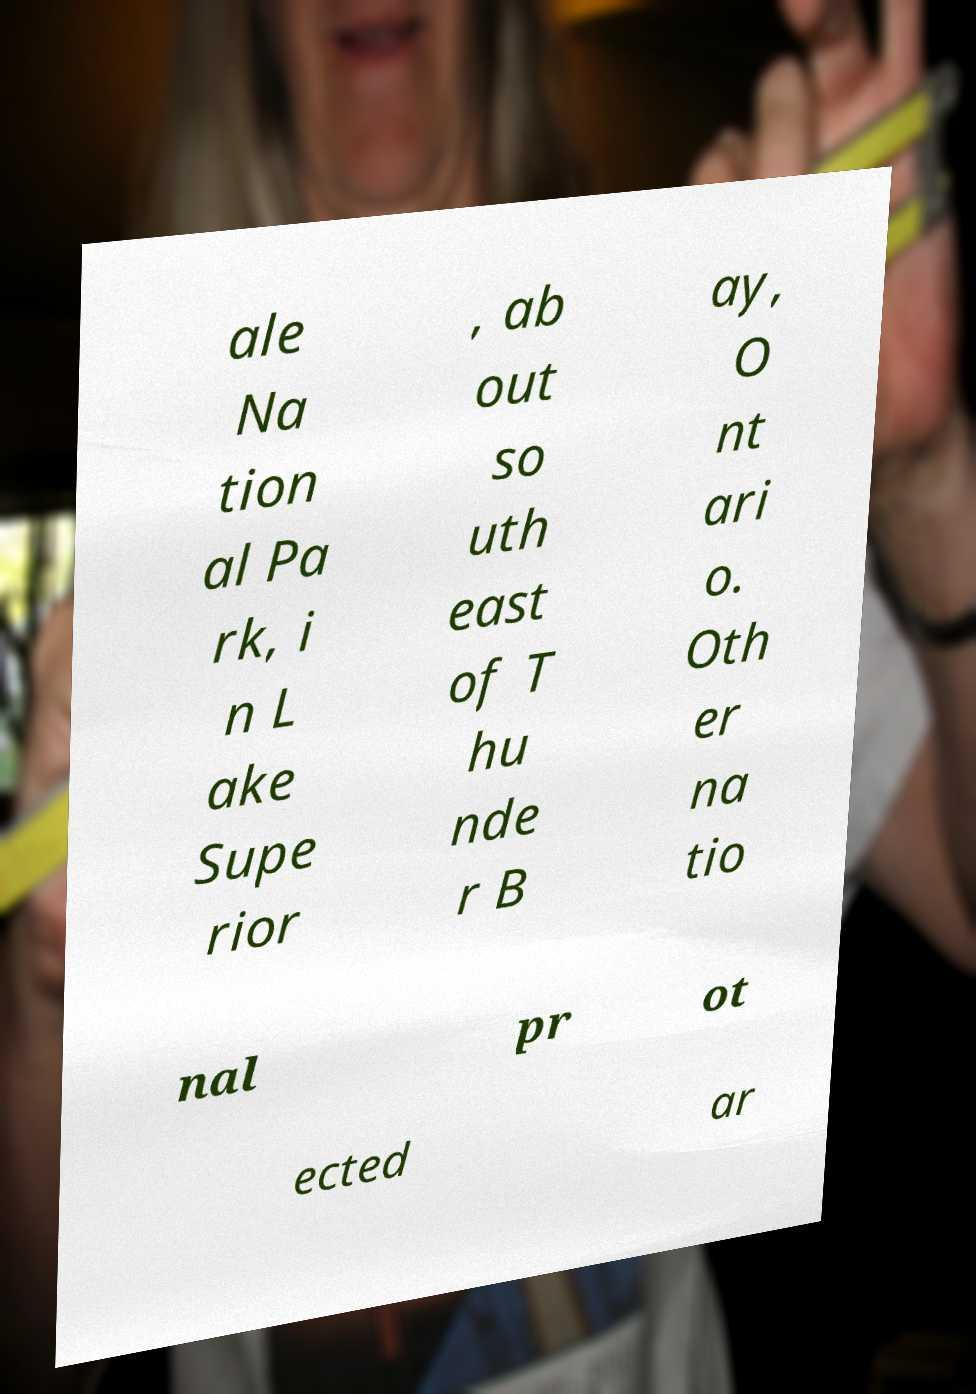Can you read and provide the text displayed in the image?This photo seems to have some interesting text. Can you extract and type it out for me? ale Na tion al Pa rk, i n L ake Supe rior , ab out so uth east of T hu nde r B ay, O nt ari o. Oth er na tio nal pr ot ected ar 